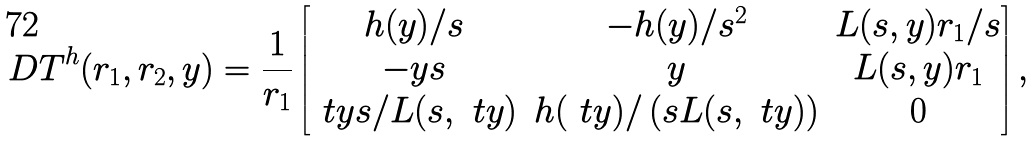Convert formula to latex. <formula><loc_0><loc_0><loc_500><loc_500>D T ^ { h } ( r _ { 1 } , r _ { 2 } , y ) = \frac { 1 } { r _ { 1 } } \begin{bmatrix} h ( y ) / s & - h ( y ) / s ^ { 2 } & L ( s , y ) r _ { 1 } / s \\ - y s & y & L ( s , y ) r _ { 1 } \\ \ t { y } s / L ( s , \ t { y } ) & h ( \ t { y } ) / \left ( s L ( s , \ t { y } ) \right ) & 0 \end{bmatrix} ,</formula> 